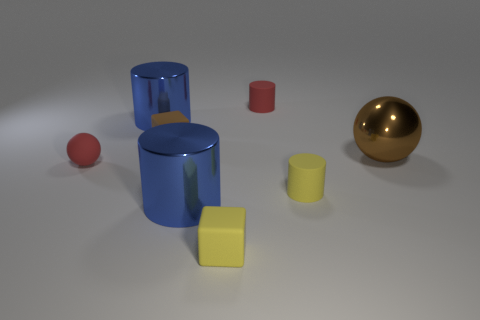Add 1 small yellow rubber blocks. How many objects exist? 9 Subtract all blocks. How many objects are left? 6 Add 3 brown objects. How many brown objects are left? 5 Add 1 blue cylinders. How many blue cylinders exist? 3 Subtract 0 cyan cylinders. How many objects are left? 8 Subtract all yellow matte balls. Subtract all tiny brown cubes. How many objects are left? 7 